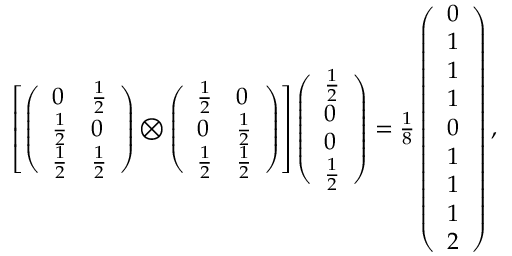Convert formula to latex. <formula><loc_0><loc_0><loc_500><loc_500>\begin{array} { r } { \left [ \left ( \begin{array} { l l } { 0 } & { \frac { 1 } { 2 } } \\ { \frac { 1 } { 2 } } & { 0 } \\ { \frac { 1 } { 2 } } & { \frac { 1 } { 2 } } \end{array} \right ) \bigotimes \left ( \begin{array} { l l } { \frac { 1 } { 2 } } & { 0 } \\ { 0 } & { \frac { 1 } { 2 } } \\ { \frac { 1 } { 2 } } & { \frac { 1 } { 2 } } \end{array} \right ) \right ] \left ( \begin{array} { l } { \frac { 1 } { 2 } } \\ { 0 } \\ { 0 } \\ { \frac { 1 } { 2 } } \end{array} \right ) = \frac { 1 } { 8 } \left ( \begin{array} { l } { 0 } \\ { 1 } \\ { 1 } \\ { 1 } \\ { 0 } \\ { 1 } \\ { 1 } \\ { 1 } \\ { 2 } \end{array} \right ) , } \end{array}</formula> 